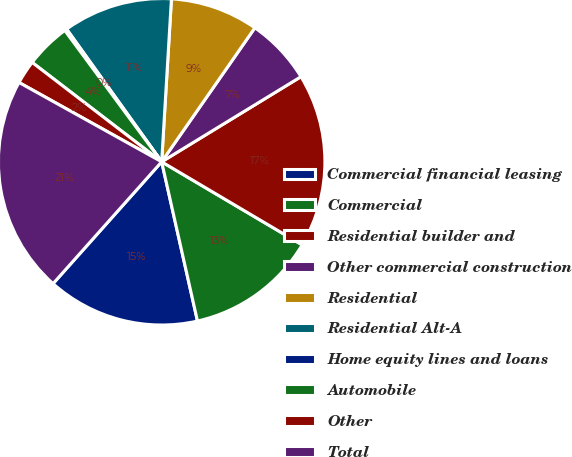Convert chart to OTSL. <chart><loc_0><loc_0><loc_500><loc_500><pie_chart><fcel>Commercial financial leasing<fcel>Commercial<fcel>Residential builder and<fcel>Other commercial construction<fcel>Residential<fcel>Residential Alt-A<fcel>Home equity lines and loans<fcel>Automobile<fcel>Other<fcel>Total<nl><fcel>15.11%<fcel>12.98%<fcel>17.23%<fcel>6.6%<fcel>8.72%<fcel>10.85%<fcel>0.22%<fcel>4.47%<fcel>2.34%<fcel>21.49%<nl></chart> 